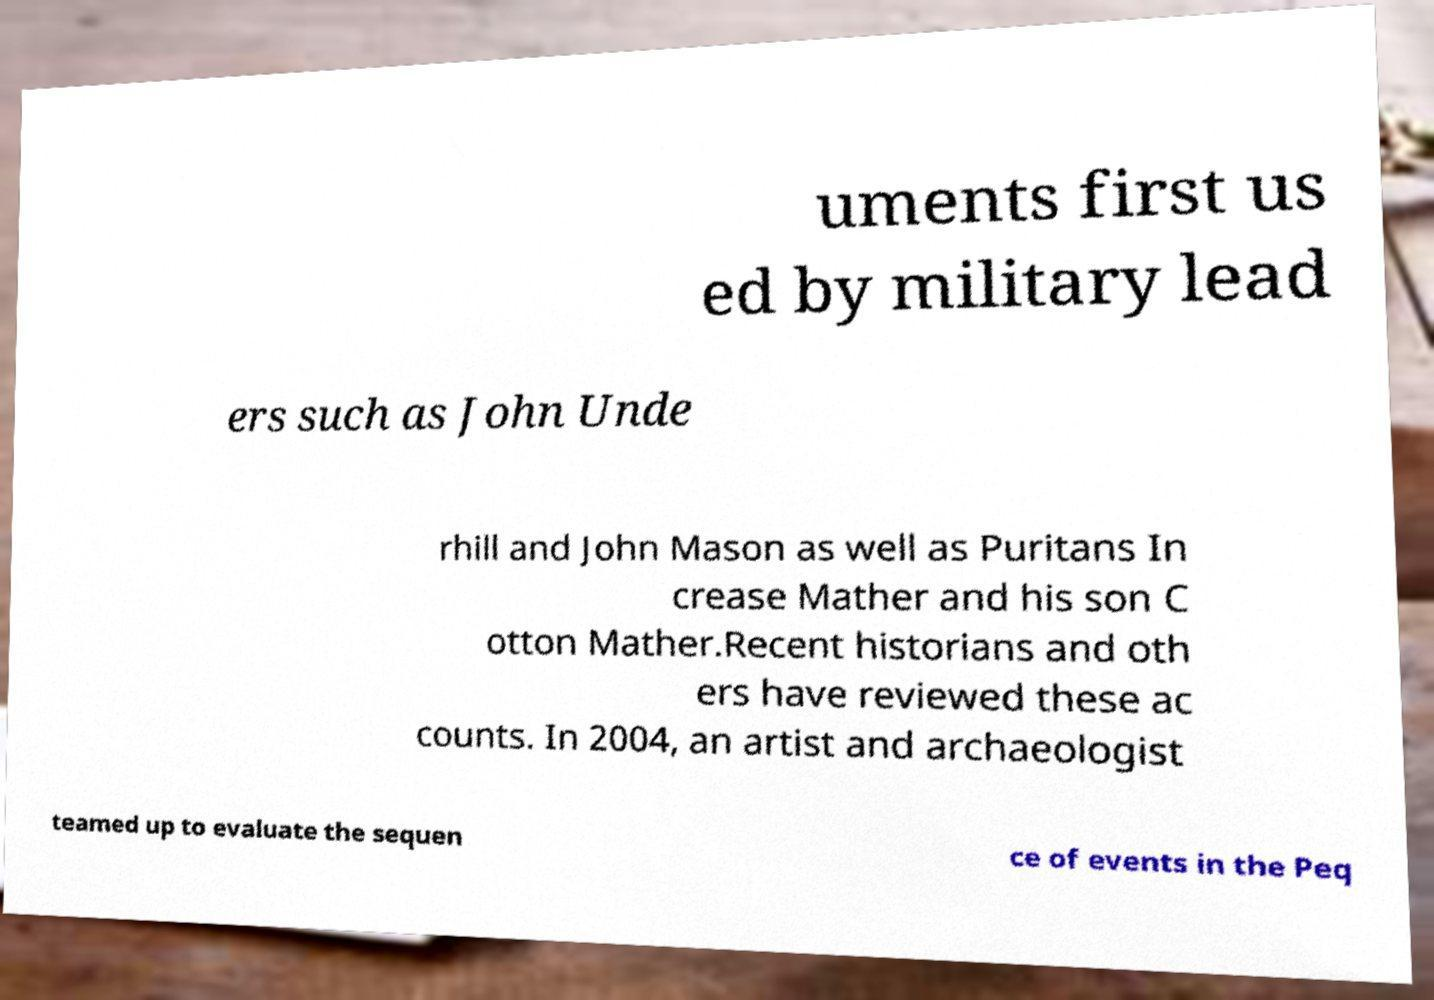Could you assist in decoding the text presented in this image and type it out clearly? uments first us ed by military lead ers such as John Unde rhill and John Mason as well as Puritans In crease Mather and his son C otton Mather.Recent historians and oth ers have reviewed these ac counts. In 2004, an artist and archaeologist teamed up to evaluate the sequen ce of events in the Peq 